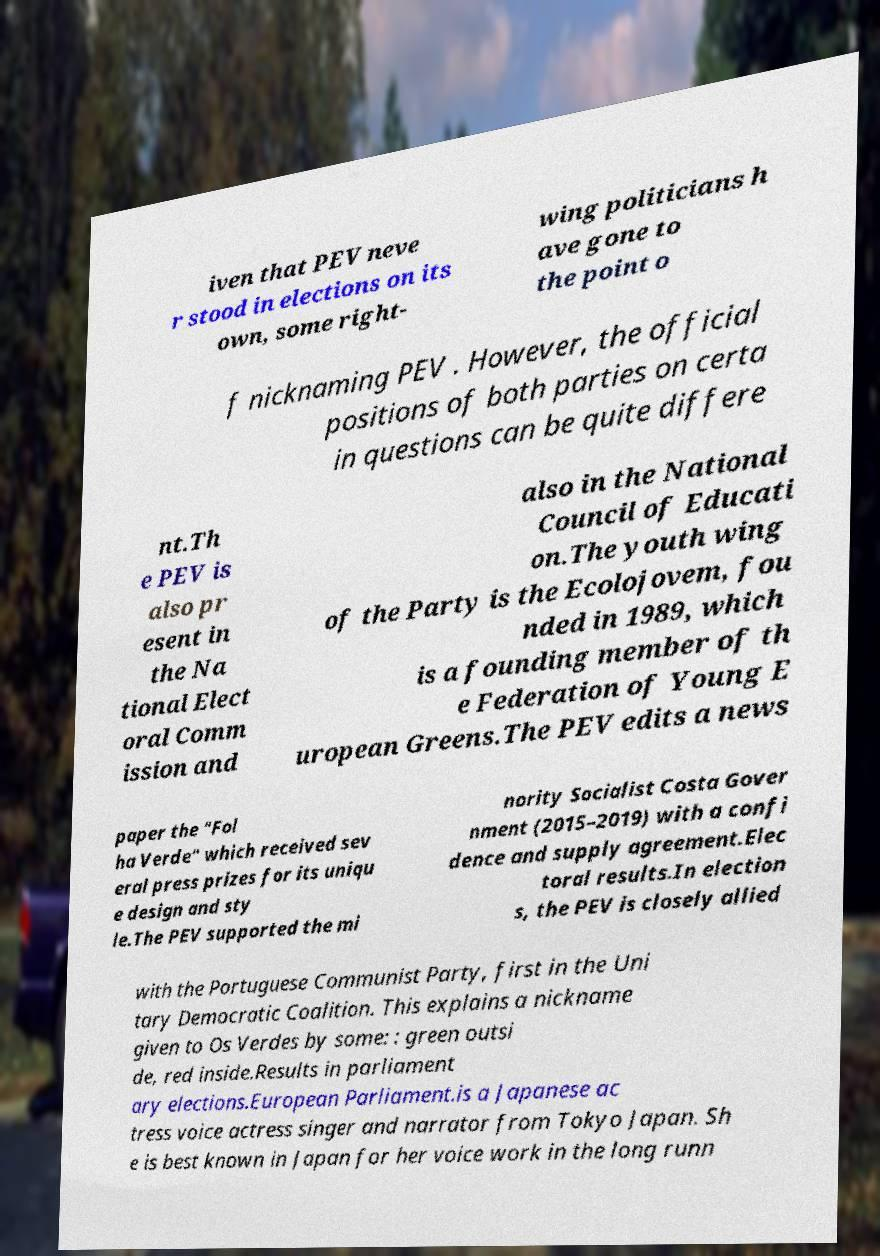Could you assist in decoding the text presented in this image and type it out clearly? iven that PEV neve r stood in elections on its own, some right- wing politicians h ave gone to the point o f nicknaming PEV . However, the official positions of both parties on certa in questions can be quite differe nt.Th e PEV is also pr esent in the Na tional Elect oral Comm ission and also in the National Council of Educati on.The youth wing of the Party is the Ecolojovem, fou nded in 1989, which is a founding member of th e Federation of Young E uropean Greens.The PEV edits a news paper the "Fol ha Verde" which received sev eral press prizes for its uniqu e design and sty le.The PEV supported the mi nority Socialist Costa Gover nment (2015–2019) with a confi dence and supply agreement.Elec toral results.In election s, the PEV is closely allied with the Portuguese Communist Party, first in the Uni tary Democratic Coalition. This explains a nickname given to Os Verdes by some: : green outsi de, red inside.Results in parliament ary elections.European Parliament.is a Japanese ac tress voice actress singer and narrator from Tokyo Japan. Sh e is best known in Japan for her voice work in the long runn 